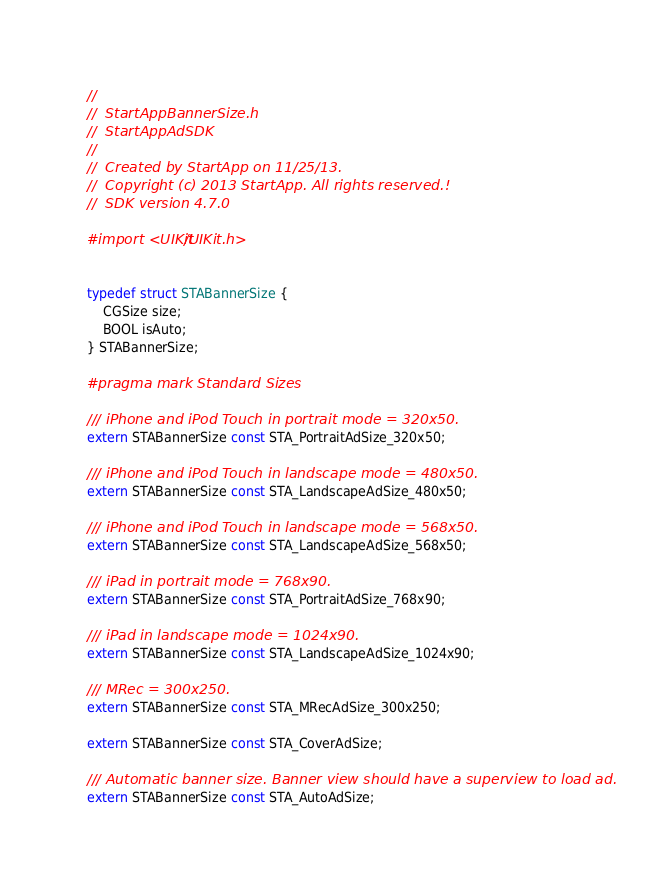<code> <loc_0><loc_0><loc_500><loc_500><_C_>//
//  StartAppBannerSize.h
//  StartAppAdSDK
//
//  Created by StartApp on 11/25/13.
//  Copyright (c) 2013 StartApp. All rights reserved.!
//  SDK version 4.7.0

#import <UIKit/UIKit.h>


typedef struct STABannerSize {
    CGSize size;
    BOOL isAuto;
} STABannerSize;

#pragma mark Standard Sizes

/// iPhone and iPod Touch in portrait mode = 320x50.
extern STABannerSize const STA_PortraitAdSize_320x50;

/// iPhone and iPod Touch in landscape mode = 480x50.
extern STABannerSize const STA_LandscapeAdSize_480x50;

/// iPhone and iPod Touch in landscape mode = 568x50.
extern STABannerSize const STA_LandscapeAdSize_568x50;

/// iPad in portrait mode = 768x90.
extern STABannerSize const STA_PortraitAdSize_768x90;

/// iPad in landscape mode = 1024x90.
extern STABannerSize const STA_LandscapeAdSize_1024x90;

/// MRec = 300x250.
extern STABannerSize const STA_MRecAdSize_300x250;

extern STABannerSize const STA_CoverAdSize;

/// Automatic banner size. Banner view should have a superview to load ad.
extern STABannerSize const STA_AutoAdSize;
</code> 